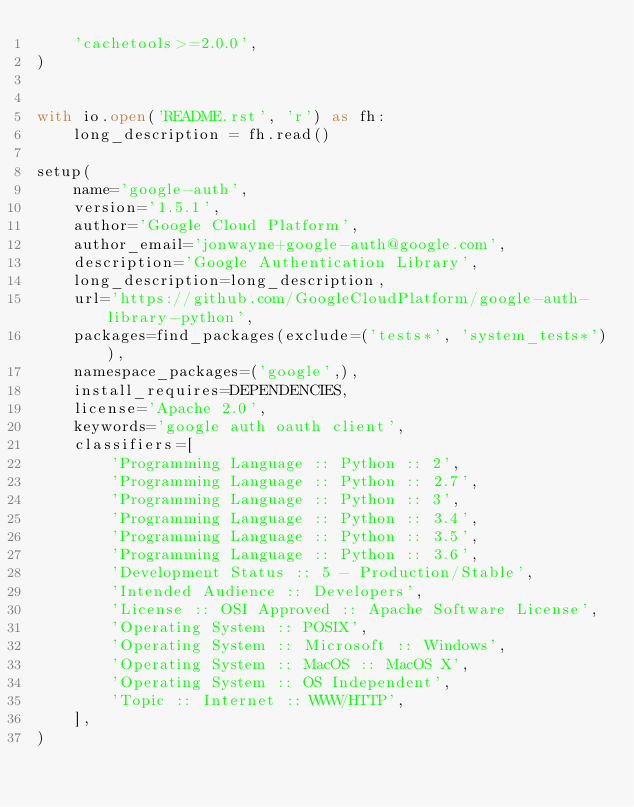<code> <loc_0><loc_0><loc_500><loc_500><_Python_>    'cachetools>=2.0.0',
)


with io.open('README.rst', 'r') as fh:
    long_description = fh.read()

setup(
    name='google-auth',
    version='1.5.1',
    author='Google Cloud Platform',
    author_email='jonwayne+google-auth@google.com',
    description='Google Authentication Library',
    long_description=long_description,
    url='https://github.com/GoogleCloudPlatform/google-auth-library-python',
    packages=find_packages(exclude=('tests*', 'system_tests*')),
    namespace_packages=('google',),
    install_requires=DEPENDENCIES,
    license='Apache 2.0',
    keywords='google auth oauth client',
    classifiers=[
        'Programming Language :: Python :: 2',
        'Programming Language :: Python :: 2.7',
        'Programming Language :: Python :: 3',
        'Programming Language :: Python :: 3.4',
        'Programming Language :: Python :: 3.5',
        'Programming Language :: Python :: 3.6',
        'Development Status :: 5 - Production/Stable',
        'Intended Audience :: Developers',
        'License :: OSI Approved :: Apache Software License',
        'Operating System :: POSIX',
        'Operating System :: Microsoft :: Windows',
        'Operating System :: MacOS :: MacOS X',
        'Operating System :: OS Independent',
        'Topic :: Internet :: WWW/HTTP',
    ],
)
</code> 